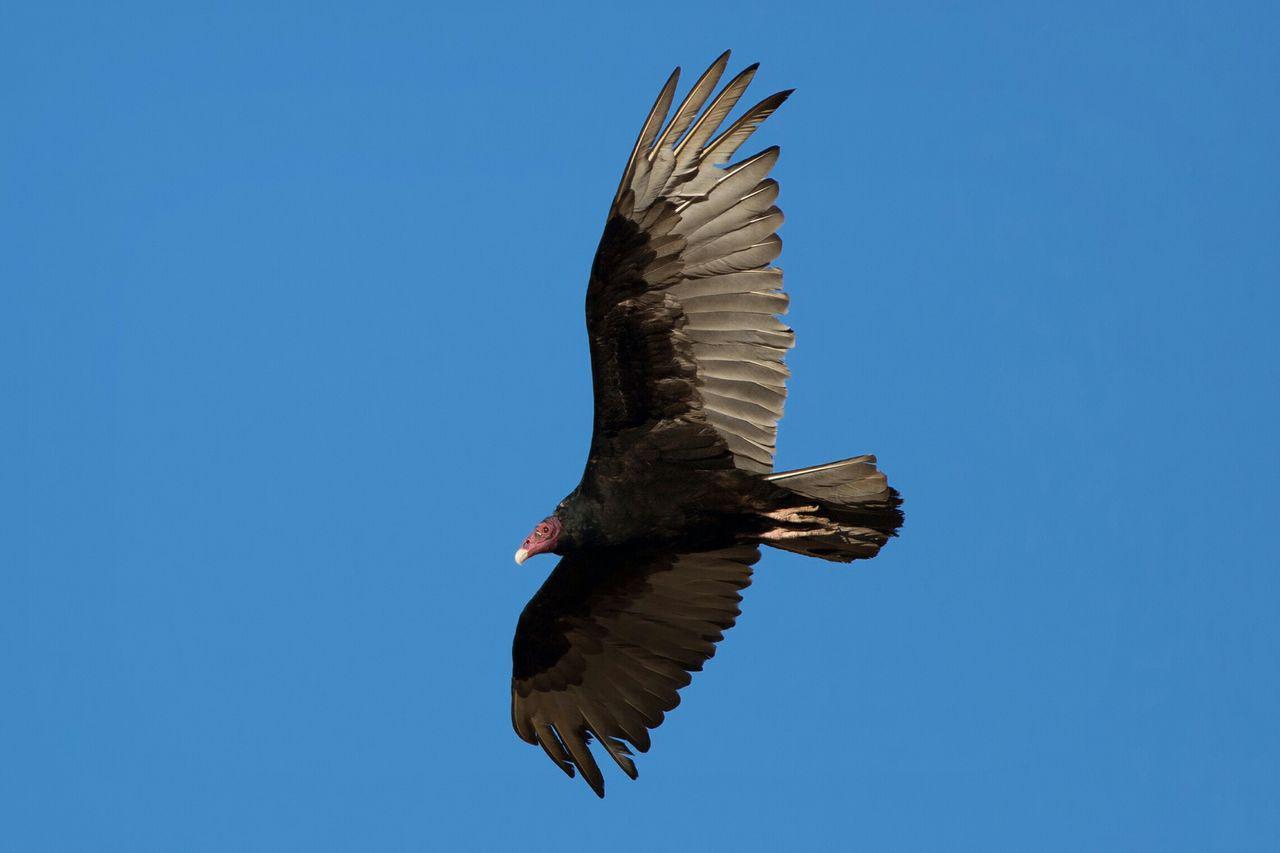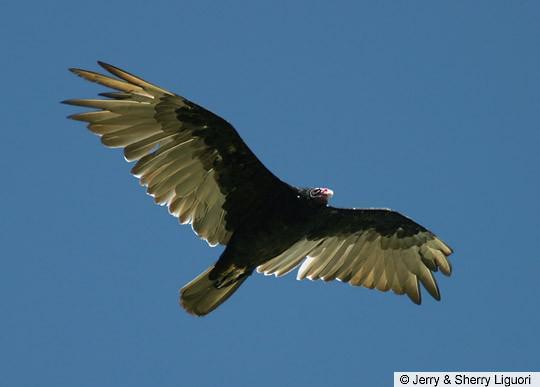The first image is the image on the left, the second image is the image on the right. Examine the images to the left and right. Is the description "There is at least one vulture with a gray head and black feathers perched upon a piece of wood." accurate? Answer yes or no. No. The first image is the image on the left, the second image is the image on the right. Examine the images to the left and right. Is the description "The bird on the left is flying in the air." accurate? Answer yes or no. Yes. 